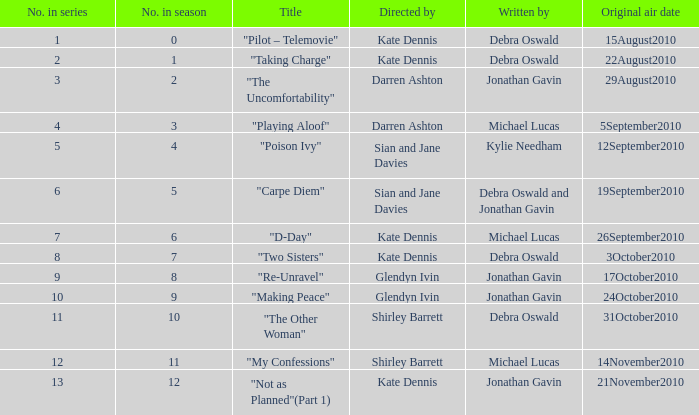When did "my confessions" make its first appearance? 14November2010. 